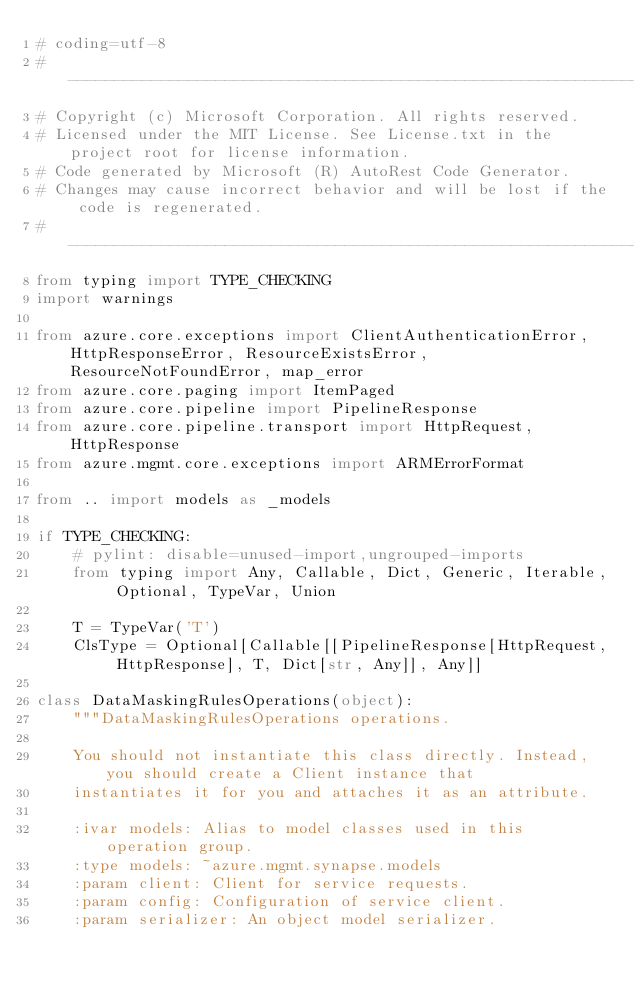Convert code to text. <code><loc_0><loc_0><loc_500><loc_500><_Python_># coding=utf-8
# --------------------------------------------------------------------------
# Copyright (c) Microsoft Corporation. All rights reserved.
# Licensed under the MIT License. See License.txt in the project root for license information.
# Code generated by Microsoft (R) AutoRest Code Generator.
# Changes may cause incorrect behavior and will be lost if the code is regenerated.
# --------------------------------------------------------------------------
from typing import TYPE_CHECKING
import warnings

from azure.core.exceptions import ClientAuthenticationError, HttpResponseError, ResourceExistsError, ResourceNotFoundError, map_error
from azure.core.paging import ItemPaged
from azure.core.pipeline import PipelineResponse
from azure.core.pipeline.transport import HttpRequest, HttpResponse
from azure.mgmt.core.exceptions import ARMErrorFormat

from .. import models as _models

if TYPE_CHECKING:
    # pylint: disable=unused-import,ungrouped-imports
    from typing import Any, Callable, Dict, Generic, Iterable, Optional, TypeVar, Union

    T = TypeVar('T')
    ClsType = Optional[Callable[[PipelineResponse[HttpRequest, HttpResponse], T, Dict[str, Any]], Any]]

class DataMaskingRulesOperations(object):
    """DataMaskingRulesOperations operations.

    You should not instantiate this class directly. Instead, you should create a Client instance that
    instantiates it for you and attaches it as an attribute.

    :ivar models: Alias to model classes used in this operation group.
    :type models: ~azure.mgmt.synapse.models
    :param client: Client for service requests.
    :param config: Configuration of service client.
    :param serializer: An object model serializer.</code> 